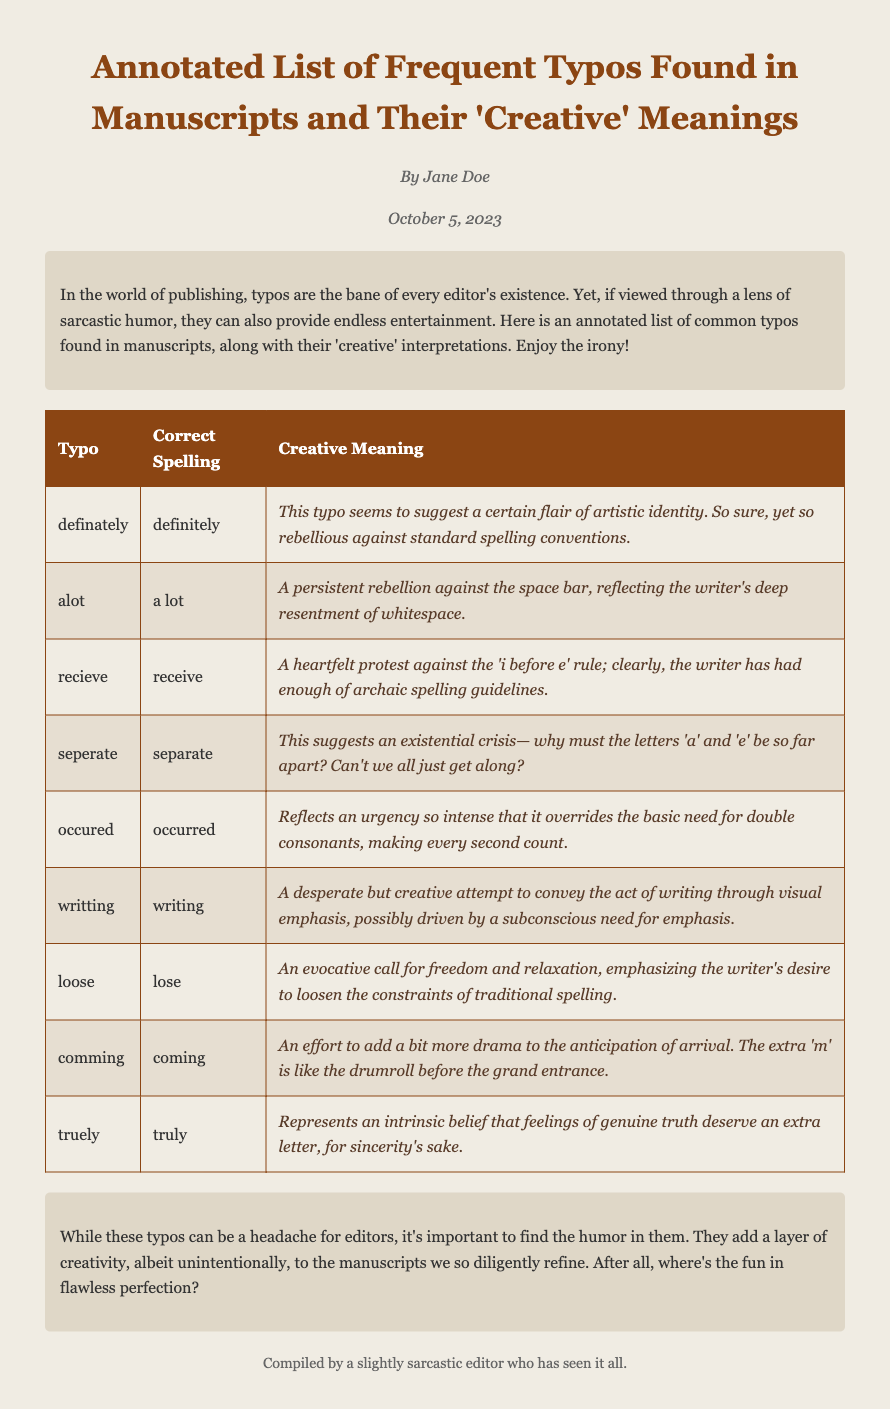what is the title of the document? The title can be found at the top of the document, indicating the content focus.
Answer: Annotated List of Frequent Typos Found in Manuscripts and Their 'Creative' Meanings who is the author of the document? The author's name is presented at the beginning of the document in a designated author section.
Answer: Jane Doe what date is listed on the document? The date is mentioned under the author's name, providing a timestamp for the content.
Answer: October 5, 2023 how many typos are listed in the table? Counting the rows in the table reveals the total number of typos included in the document.
Answer: 10 what is the creative meaning of the typo "alot"? The creative meaning is explained in the table under the corresponding typo category.
Answer: A persistent rebellion against the space bar, reflecting the writer's deep resentment of whitespace what is the underlying theme of the introduction? The introduction serves to establish the document's humorous and ironic perspective on typos.
Answer: Humor in typos what does the conclusion suggest about typos? The conclusion summarizes the overall sentiment towards typos, indicating a positive outlook.
Answer: Add a layer of creativity what type of guide is this document? The document categorizes and presents information in a specific manner typical of a humorous guide.
Answer: Sarcastic guide 